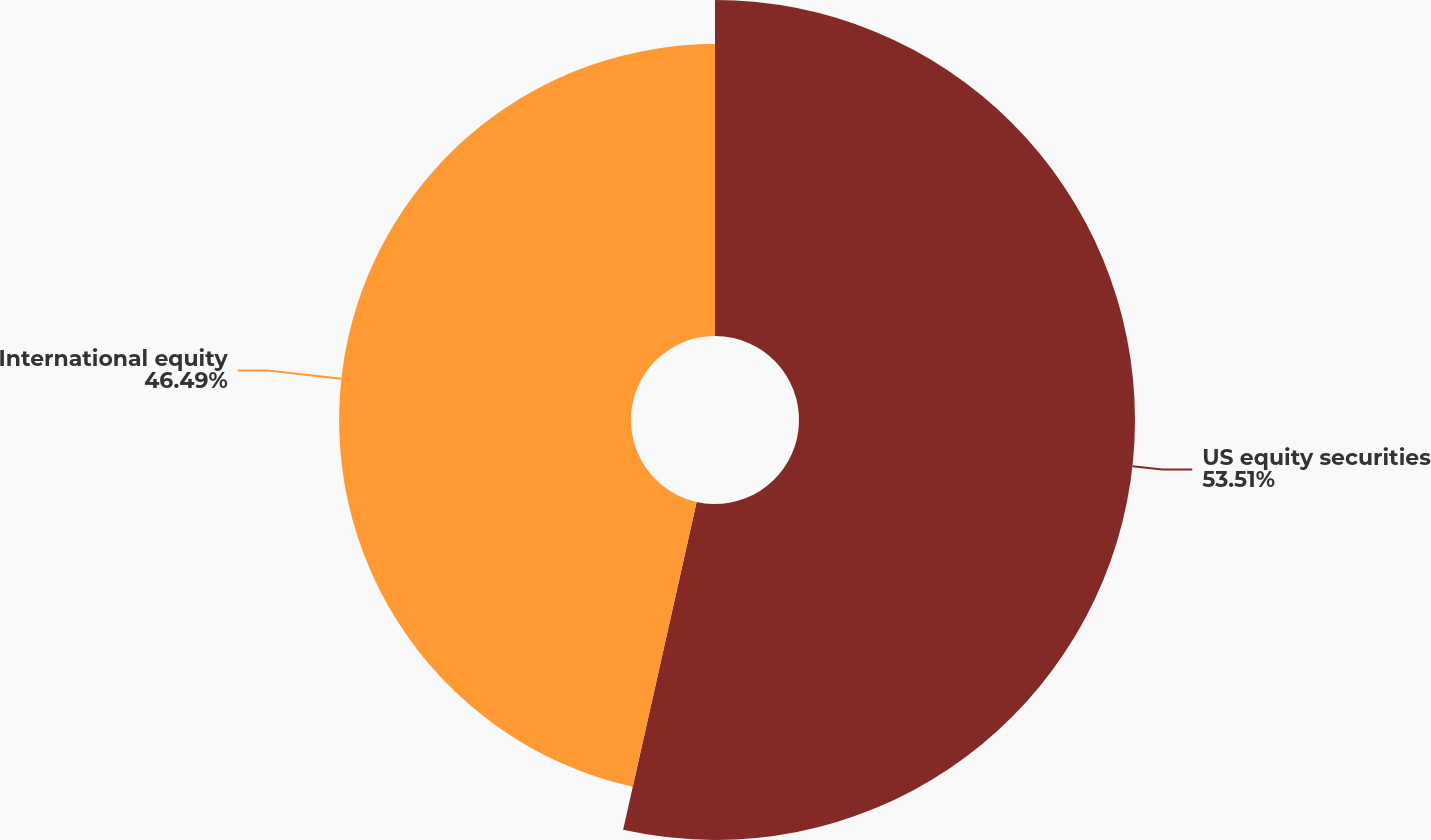Convert chart to OTSL. <chart><loc_0><loc_0><loc_500><loc_500><pie_chart><fcel>US equity securities<fcel>International equity<nl><fcel>53.51%<fcel>46.49%<nl></chart> 